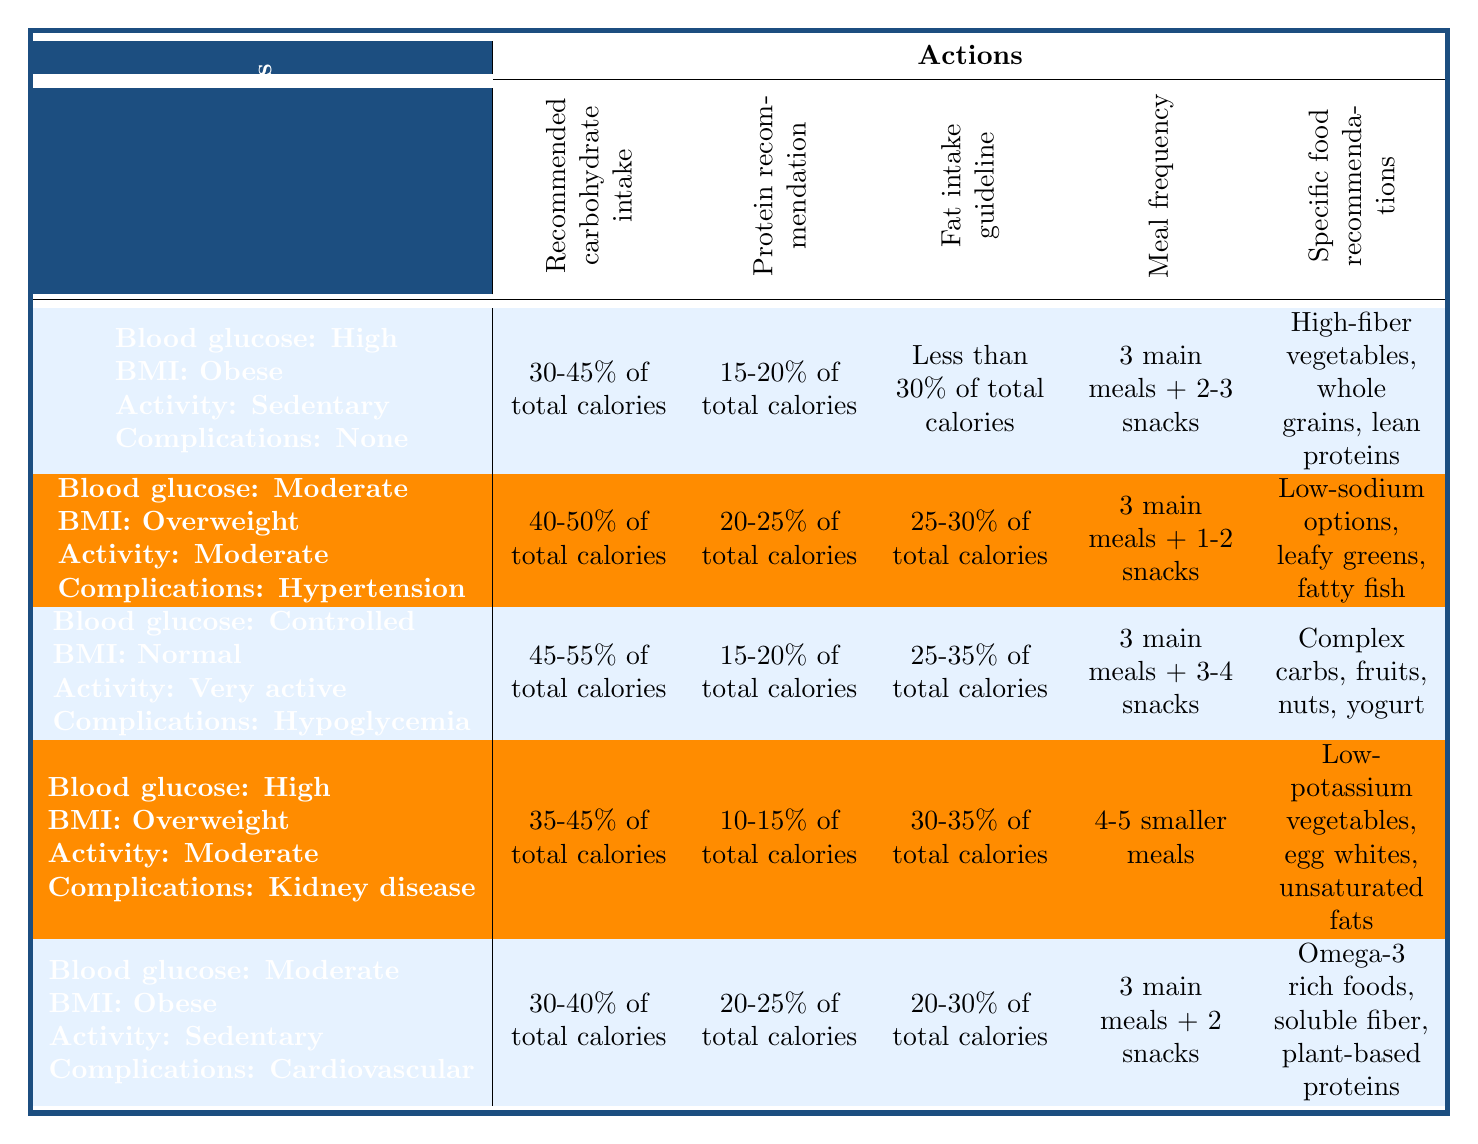What is the recommended carbohydrate intake for individuals with high blood glucose levels and obesity, who are sedentary and have no complications? The relevant row in the table specifies that for those conditions, the recommended carbohydrate intake is 30-45% of total calories.
Answer: 30-45% of total calories What meal frequency is suggested for moderately active individuals with moderately high blood glucose levels and hypertension? Checking the conditions for this specific case, the table indicates the meal frequency as 3 main meals + 1-2 snacks.
Answer: 3 main meals + 1-2 snacks For a person with high blood glucose, obesity, and cardiovascular disease, what is the recommended protein percentage of total calories? The table indicates that for these conditions, the protein recommendation is 20-25% of total calories.
Answer: 20-25% of total calories Is the fat intake guideline for someone with well-controlled blood glucose and normal BMI higher than that for someone with high blood glucose and kidney disease? The fat intake for well-controlled blood glucose and normal BMI is 25-35% of total calories, while for high blood glucose and kidney disease, it is 30-35% of total calories. Therefore, the fat guideline for high blood glucose and kidney disease is higher.
Answer: Yes If a patient with high blood glucose and obesity has cardiovascular disease, what are the specific food recommendations? According to the relevant row, the specific food recommendations include omega-3 rich foods, soluble fiber, and plant-based proteins.
Answer: Omega-3 rich foods, soluble fiber, plant-based proteins What is the average recommended protein intake percentage for individuals classified as obese with moderately high blood glucose and those categorized as normal with controlled blood glucose? For the obese with moderately high blood glucose, the recommended protein intake is 20-25%, and for the normal with controlled blood glucose, it is 15-20%. To find the average, calculate (22.5 + 17.5) / 2 = 20%.
Answer: 20% How many conditions correspond to a carbohydrate intake recommendation of 40-50% of total calories? Two specific conditions in the table indicate a carbohydrate recommendation of 40-50%: 1) moderately high blood glucose with overweight and hypertension, and 2) high blood glucose with overweight and kidney disease. Thus, the total number of conditions is two.
Answer: 2 For individuals who are very active with well-controlled blood glucose and normal BMI, how many snacks are recommended? The corresponding row in the table states that this condition allows for 3-4 snacks in addition to the 3 main meals.
Answer: 3-4 snacks 